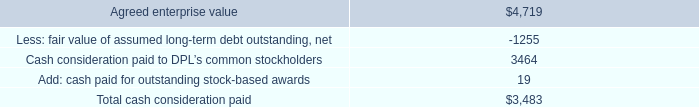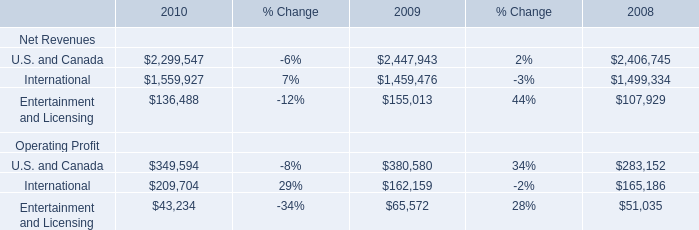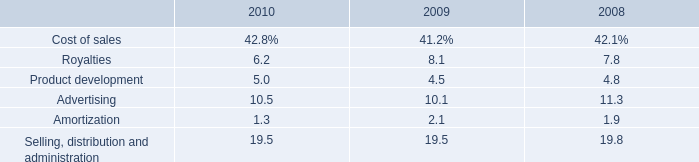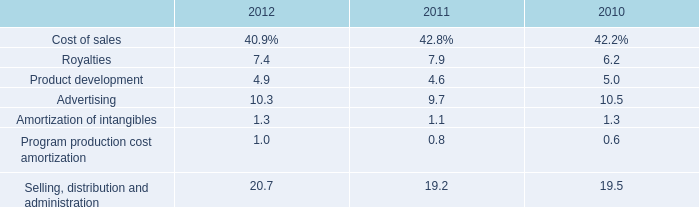What is the value of the Operating Profit for Entertainment and Licensing in the year where Net Revenues for Entertainment and Licensing is greater than 150000? 
Answer: 65572. 